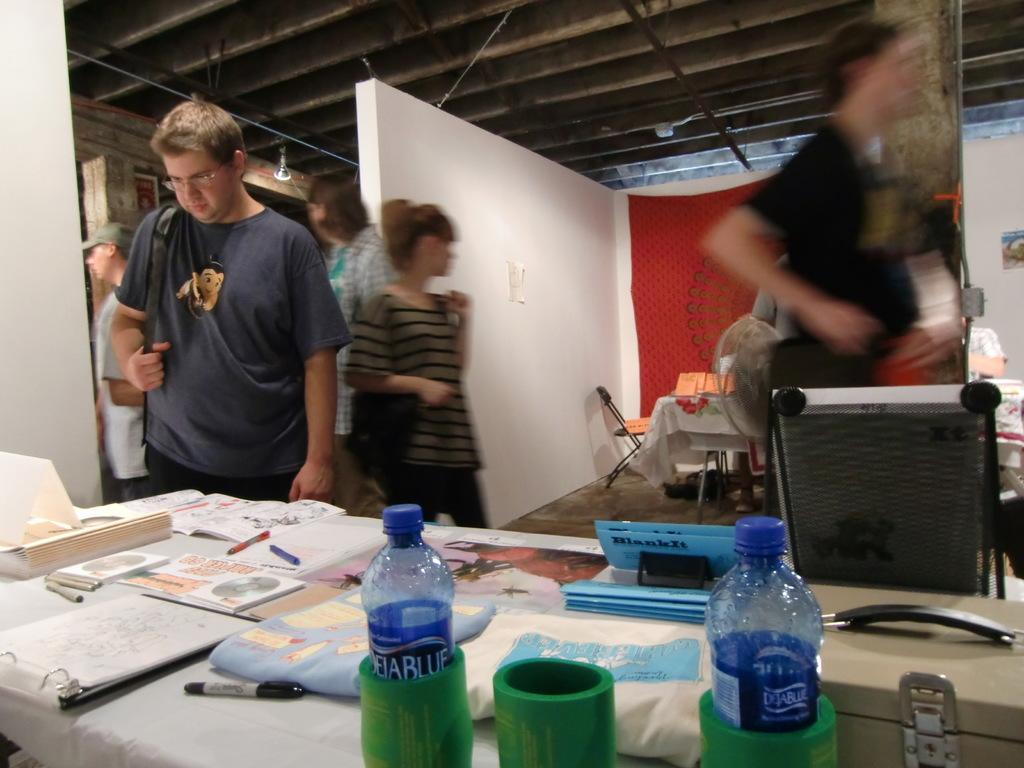<image>
Offer a succinct explanation of the picture presented. A room with tables that have DejaBlue water bottles on them and people walking by. 